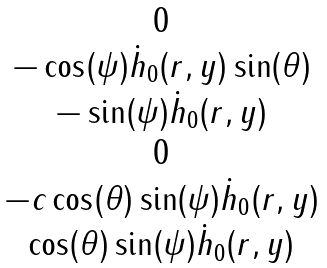<formula> <loc_0><loc_0><loc_500><loc_500>\begin{matrix} 0 \\ - \cos ( \psi ) \dot { h } _ { 0 } ( r , y ) \sin ( \theta ) \\ - \sin ( \psi ) \dot { h } _ { 0 } ( r , y ) \\ 0 \\ - c \cos ( \theta ) \sin ( \psi ) \dot { h } _ { 0 } ( r , y ) \\ \cos ( \theta ) \sin ( \psi ) \dot { h } _ { 0 } ( r , y ) \end{matrix}</formula> 